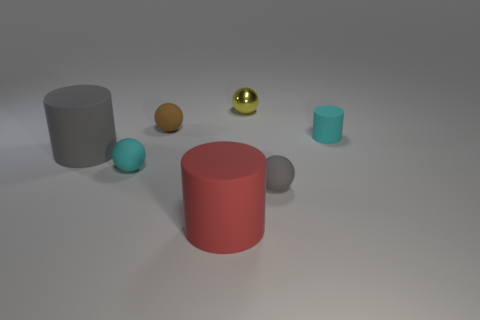There is a cyan matte object that is in front of the cyan cylinder; is its shape the same as the gray rubber thing right of the brown thing? Yes, the shape of the cyan matte object positioned in front of the cyan cylinder is identical to that of the gray rubber object located to the right of the brown object. They both appear to be spheres, sharing the characteristic round and symmetrical form. 